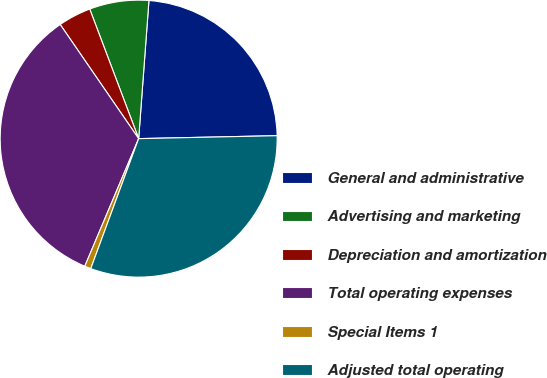<chart> <loc_0><loc_0><loc_500><loc_500><pie_chart><fcel>General and administrative<fcel>Advertising and marketing<fcel>Depreciation and amortization<fcel>Total operating expenses<fcel>Special Items 1<fcel>Adjusted total operating<nl><fcel>23.48%<fcel>6.93%<fcel>3.84%<fcel>34.06%<fcel>0.74%<fcel>30.96%<nl></chart> 